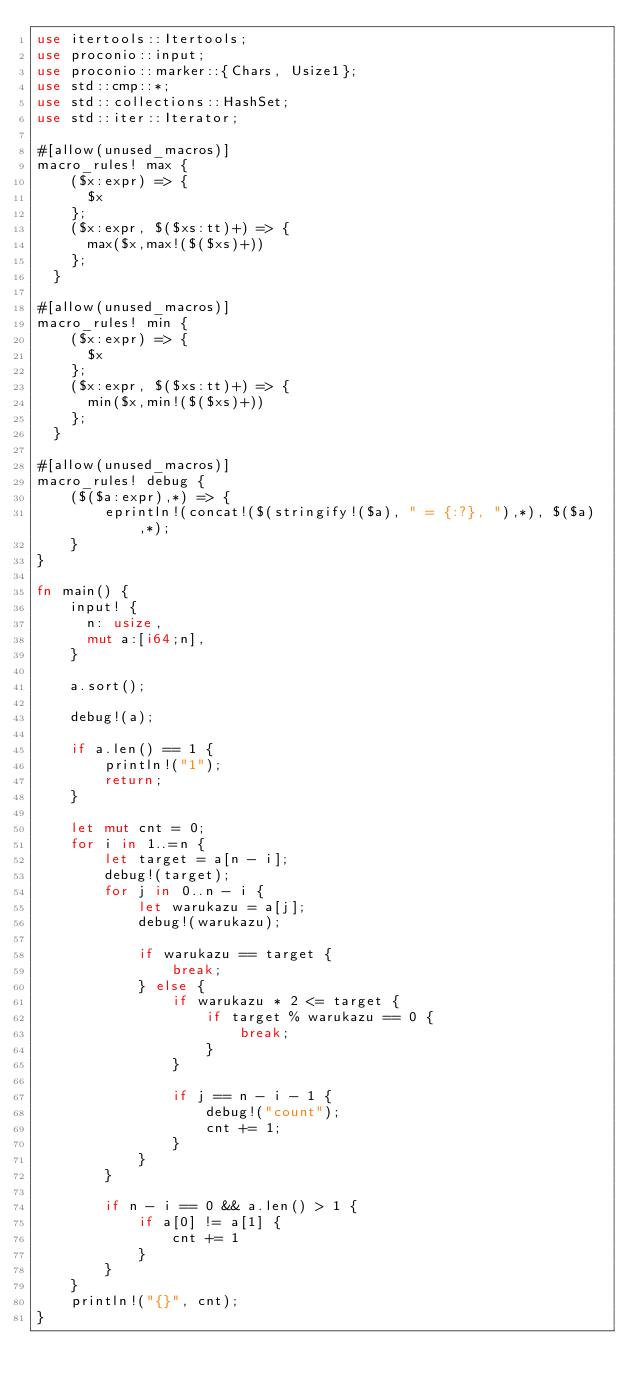Convert code to text. <code><loc_0><loc_0><loc_500><loc_500><_Rust_>use itertools::Itertools;
use proconio::input;
use proconio::marker::{Chars, Usize1};
use std::cmp::*;
use std::collections::HashSet;
use std::iter::Iterator;

#[allow(unused_macros)]
macro_rules! max {
    ($x:expr) => {
      $x
    };
    ($x:expr, $($xs:tt)+) => {
      max($x,max!($($xs)+))
    };
  }

#[allow(unused_macros)]
macro_rules! min {
    ($x:expr) => {
      $x
    };
    ($x:expr, $($xs:tt)+) => {
      min($x,min!($($xs)+))
    };
  }

#[allow(unused_macros)]
macro_rules! debug {
    ($($a:expr),*) => {
        eprintln!(concat!($(stringify!($a), " = {:?}, "),*), $($a),*);
    }
}

fn main() {
    input! {
      n: usize,
      mut a:[i64;n],
    }

    a.sort();

    debug!(a);

    if a.len() == 1 {
        println!("1");
        return;
    }

    let mut cnt = 0;
    for i in 1..=n {
        let target = a[n - i];
        debug!(target);
        for j in 0..n - i {
            let warukazu = a[j];
            debug!(warukazu);

            if warukazu == target {
                break;
            } else {
                if warukazu * 2 <= target {
                    if target % warukazu == 0 {
                        break;
                    }
                }

                if j == n - i - 1 {
                    debug!("count");
                    cnt += 1;
                }
            }
        }

        if n - i == 0 && a.len() > 1 {
            if a[0] != a[1] {
                cnt += 1
            }
        }
    }
    println!("{}", cnt);
}
</code> 